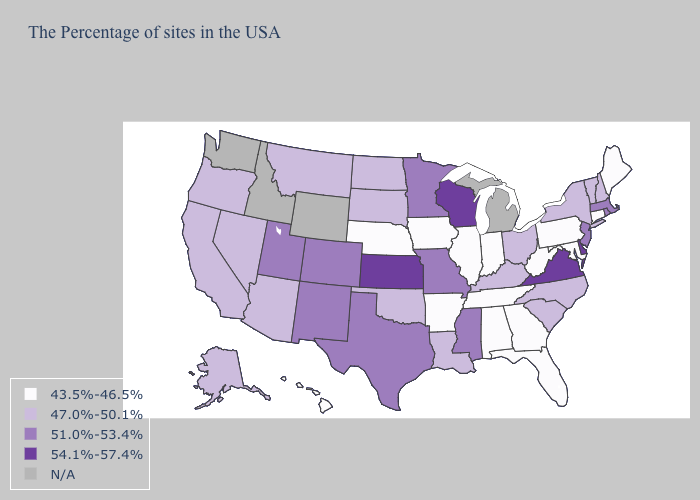What is the value of Florida?
Short answer required. 43.5%-46.5%. What is the highest value in the USA?
Be succinct. 54.1%-57.4%. Is the legend a continuous bar?
Quick response, please. No. Name the states that have a value in the range 43.5%-46.5%?
Keep it brief. Maine, Connecticut, Maryland, Pennsylvania, West Virginia, Florida, Georgia, Indiana, Alabama, Tennessee, Illinois, Arkansas, Iowa, Nebraska, Hawaii. Name the states that have a value in the range 54.1%-57.4%?
Keep it brief. Delaware, Virginia, Wisconsin, Kansas. Which states have the lowest value in the Northeast?
Keep it brief. Maine, Connecticut, Pennsylvania. What is the value of Indiana?
Concise answer only. 43.5%-46.5%. What is the value of Georgia?
Quick response, please. 43.5%-46.5%. How many symbols are there in the legend?
Short answer required. 5. What is the value of Oklahoma?
Keep it brief. 47.0%-50.1%. Does Maine have the highest value in the USA?
Give a very brief answer. No. How many symbols are there in the legend?
Be succinct. 5. Name the states that have a value in the range 54.1%-57.4%?
Quick response, please. Delaware, Virginia, Wisconsin, Kansas. Among the states that border Georgia , which have the highest value?
Short answer required. North Carolina, South Carolina. 